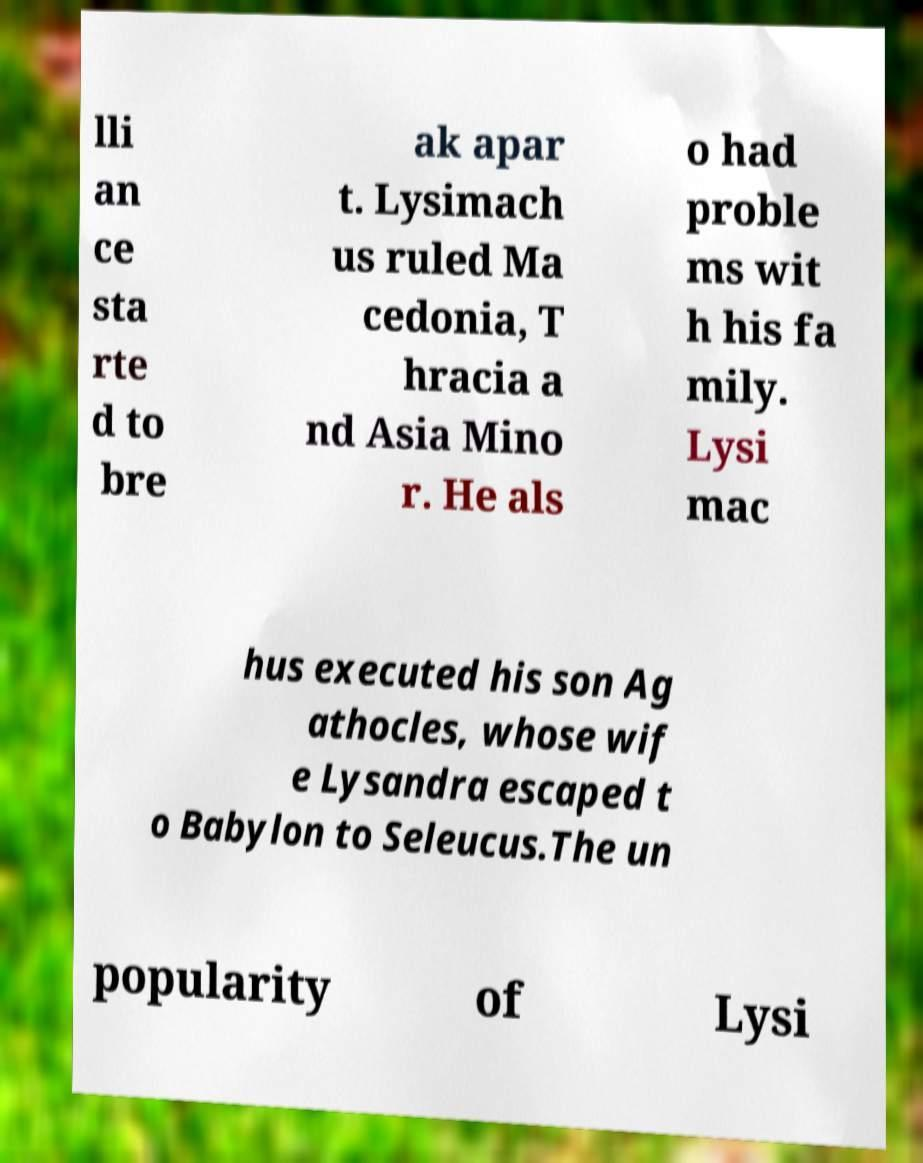I need the written content from this picture converted into text. Can you do that? lli an ce sta rte d to bre ak apar t. Lysimach us ruled Ma cedonia, T hracia a nd Asia Mino r. He als o had proble ms wit h his fa mily. Lysi mac hus executed his son Ag athocles, whose wif e Lysandra escaped t o Babylon to Seleucus.The un popularity of Lysi 